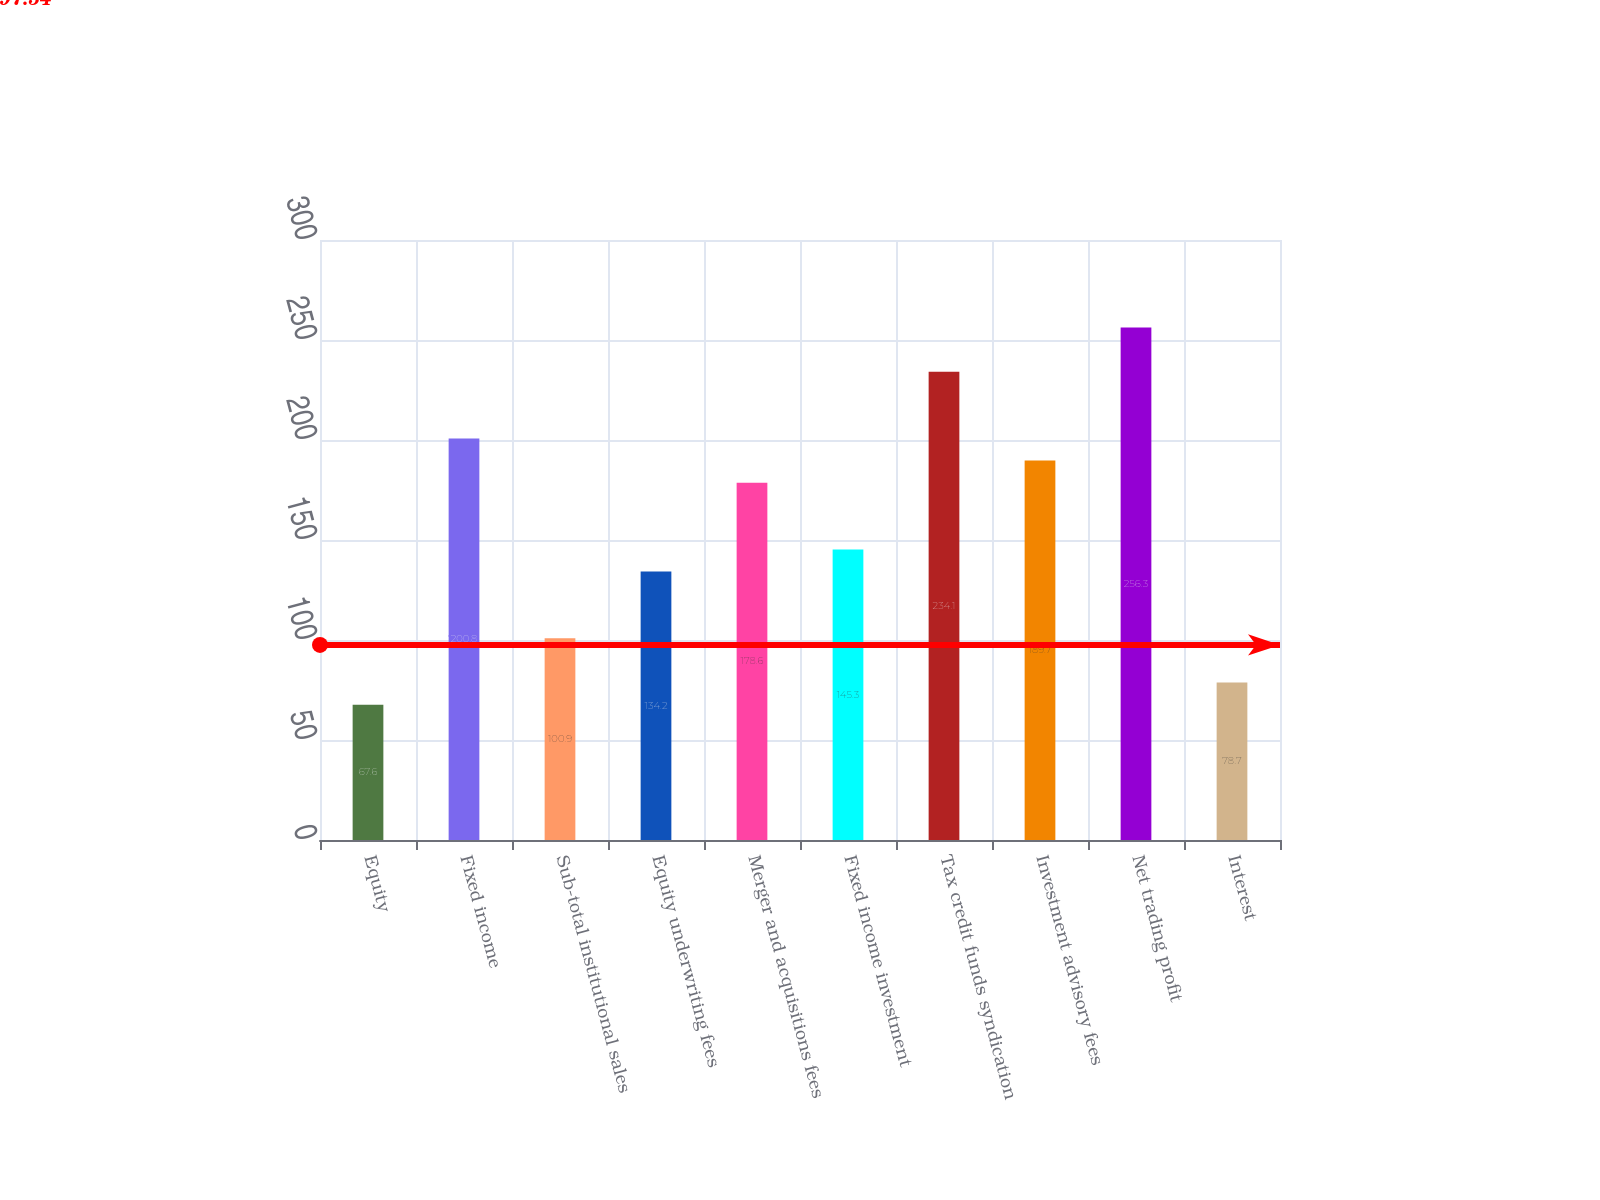Convert chart. <chart><loc_0><loc_0><loc_500><loc_500><bar_chart><fcel>Equity<fcel>Fixed income<fcel>Sub-total institutional sales<fcel>Equity underwriting fees<fcel>Merger and acquisitions fees<fcel>Fixed income investment<fcel>Tax credit funds syndication<fcel>Investment advisory fees<fcel>Net trading profit<fcel>Interest<nl><fcel>67.6<fcel>200.8<fcel>100.9<fcel>134.2<fcel>178.6<fcel>145.3<fcel>234.1<fcel>189.7<fcel>256.3<fcel>78.7<nl></chart> 